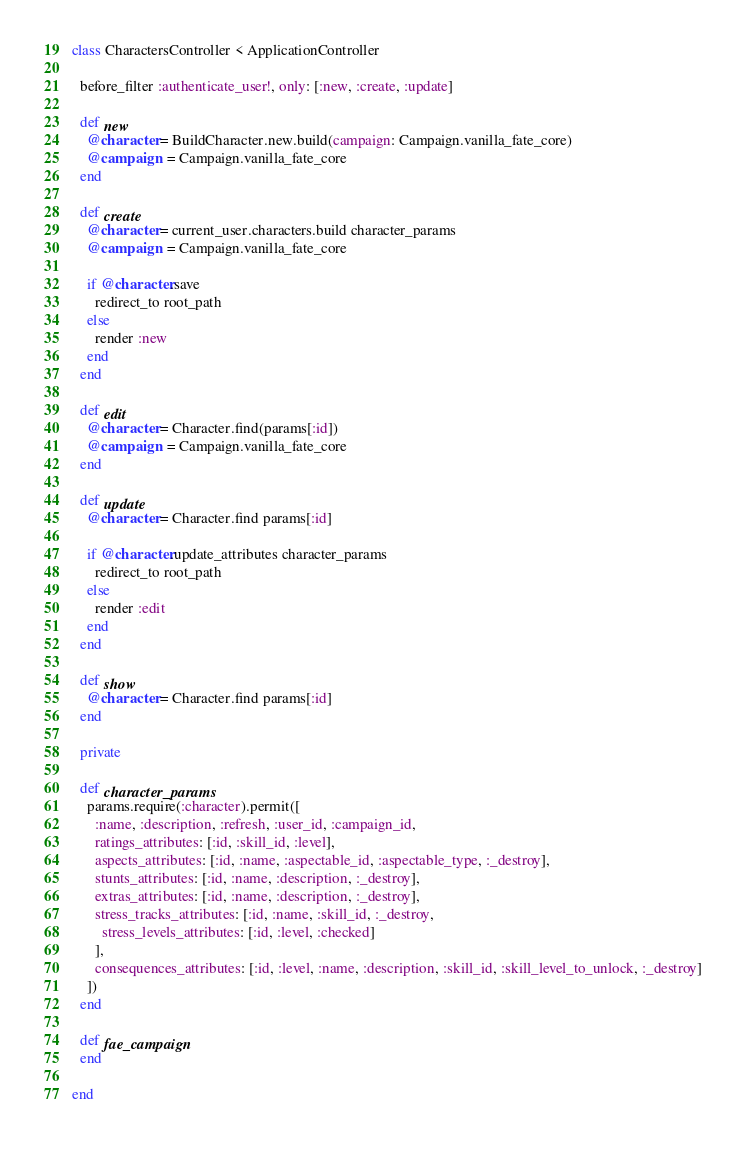Convert code to text. <code><loc_0><loc_0><loc_500><loc_500><_Ruby_>class CharactersController < ApplicationController

  before_filter :authenticate_user!, only: [:new, :create, :update]

  def new
    @character = BuildCharacter.new.build(campaign: Campaign.vanilla_fate_core)
    @campaign  = Campaign.vanilla_fate_core
  end

  def create
    @character = current_user.characters.build character_params
    @campaign  = Campaign.vanilla_fate_core

    if @character.save
      redirect_to root_path
    else
      render :new
    end
  end

  def edit
    @character = Character.find(params[:id])
    @campaign  = Campaign.vanilla_fate_core
  end

  def update
    @character = Character.find params[:id]

    if @character.update_attributes character_params
      redirect_to root_path
    else
      render :edit
    end
  end

  def show
    @character = Character.find params[:id]
  end

  private

  def character_params
    params.require(:character).permit([
      :name, :description, :refresh, :user_id, :campaign_id,
      ratings_attributes: [:id, :skill_id, :level],
      aspects_attributes: [:id, :name, :aspectable_id, :aspectable_type, :_destroy],
      stunts_attributes: [:id, :name, :description, :_destroy],
      extras_attributes: [:id, :name, :description, :_destroy],
      stress_tracks_attributes: [:id, :name, :skill_id, :_destroy,
        stress_levels_attributes: [:id, :level, :checked]
      ],
      consequences_attributes: [:id, :level, :name, :description, :skill_id, :skill_level_to_unlock, :_destroy]
    ])
  end

  def fae_campaign
  end

end
</code> 